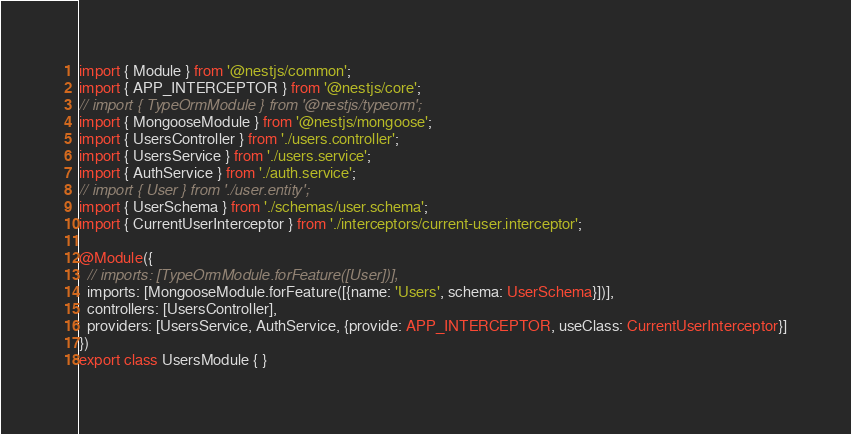Convert code to text. <code><loc_0><loc_0><loc_500><loc_500><_TypeScript_>import { Module } from '@nestjs/common';
import { APP_INTERCEPTOR } from '@nestjs/core';
// import { TypeOrmModule } from '@nestjs/typeorm';
import { MongooseModule } from '@nestjs/mongoose';
import { UsersController } from './users.controller';
import { UsersService } from './users.service';
import { AuthService } from './auth.service';
// import { User } from './user.entity';
import { UserSchema } from './schemas/user.schema';
import { CurrentUserInterceptor } from './interceptors/current-user.interceptor';

@Module({
  // imports: [TypeOrmModule.forFeature([User])],
  imports: [MongooseModule.forFeature([{name: 'Users', schema: UserSchema}])],
  controllers: [UsersController],
  providers: [UsersService, AuthService, {provide: APP_INTERCEPTOR, useClass: CurrentUserInterceptor}]
})
export class UsersModule { }
</code> 